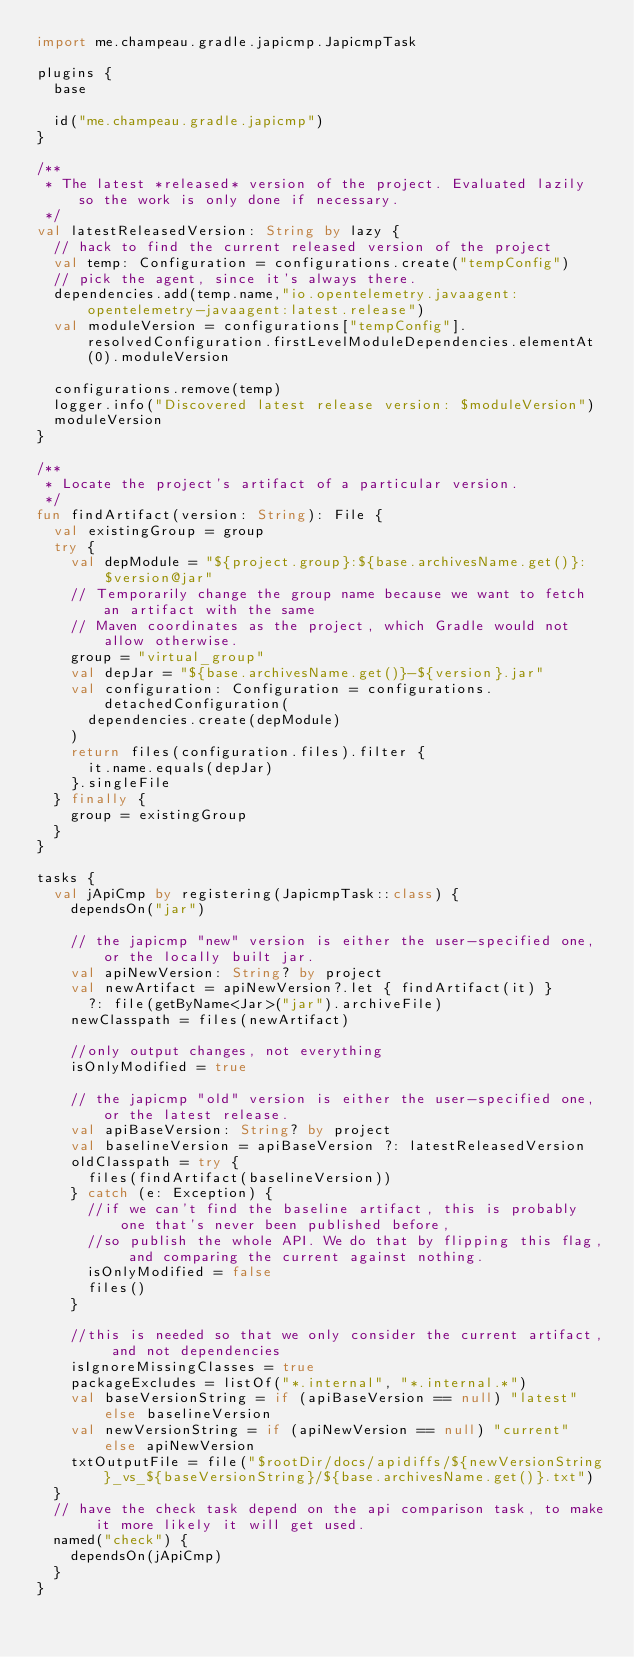<code> <loc_0><loc_0><loc_500><loc_500><_Kotlin_>import me.champeau.gradle.japicmp.JapicmpTask

plugins {
  base

  id("me.champeau.gradle.japicmp")
}

/**
 * The latest *released* version of the project. Evaluated lazily so the work is only done if necessary.
 */
val latestReleasedVersion: String by lazy {
  // hack to find the current released version of the project
  val temp: Configuration = configurations.create("tempConfig")
  // pick the agent, since it's always there.
  dependencies.add(temp.name,"io.opentelemetry.javaagent:opentelemetry-javaagent:latest.release")
  val moduleVersion = configurations["tempConfig"].resolvedConfiguration.firstLevelModuleDependencies.elementAt(0).moduleVersion

  configurations.remove(temp)
  logger.info("Discovered latest release version: $moduleVersion")
  moduleVersion
}

/**
 * Locate the project's artifact of a particular version.
 */
fun findArtifact(version: String): File {
  val existingGroup = group
  try {
    val depModule = "${project.group}:${base.archivesName.get()}:$version@jar"
    // Temporarily change the group name because we want to fetch an artifact with the same
    // Maven coordinates as the project, which Gradle would not allow otherwise.
    group = "virtual_group"
    val depJar = "${base.archivesName.get()}-${version}.jar"
    val configuration: Configuration = configurations.detachedConfiguration(
      dependencies.create(depModule)
    )
    return files(configuration.files).filter {
      it.name.equals(depJar)
    }.singleFile
  } finally {
    group = existingGroup
  }
}

tasks {
  val jApiCmp by registering(JapicmpTask::class) {
    dependsOn("jar")

    // the japicmp "new" version is either the user-specified one, or the locally built jar.
    val apiNewVersion: String? by project
    val newArtifact = apiNewVersion?.let { findArtifact(it) }
      ?: file(getByName<Jar>("jar").archiveFile)
    newClasspath = files(newArtifact)

    //only output changes, not everything
    isOnlyModified = true

    // the japicmp "old" version is either the user-specified one, or the latest release.
    val apiBaseVersion: String? by project
    val baselineVersion = apiBaseVersion ?: latestReleasedVersion
    oldClasspath = try {
      files(findArtifact(baselineVersion))
    } catch (e: Exception) {
      //if we can't find the baseline artifact, this is probably one that's never been published before,
      //so publish the whole API. We do that by flipping this flag, and comparing the current against nothing.
      isOnlyModified = false
      files()
    }

    //this is needed so that we only consider the current artifact, and not dependencies
    isIgnoreMissingClasses = true
    packageExcludes = listOf("*.internal", "*.internal.*")
    val baseVersionString = if (apiBaseVersion == null) "latest" else baselineVersion
    val newVersionString = if (apiNewVersion == null) "current" else apiNewVersion
    txtOutputFile = file("$rootDir/docs/apidiffs/${newVersionString}_vs_${baseVersionString}/${base.archivesName.get()}.txt")
  }
  // have the check task depend on the api comparison task, to make it more likely it will get used.
  named("check") {
    dependsOn(jApiCmp)
  }
}

</code> 